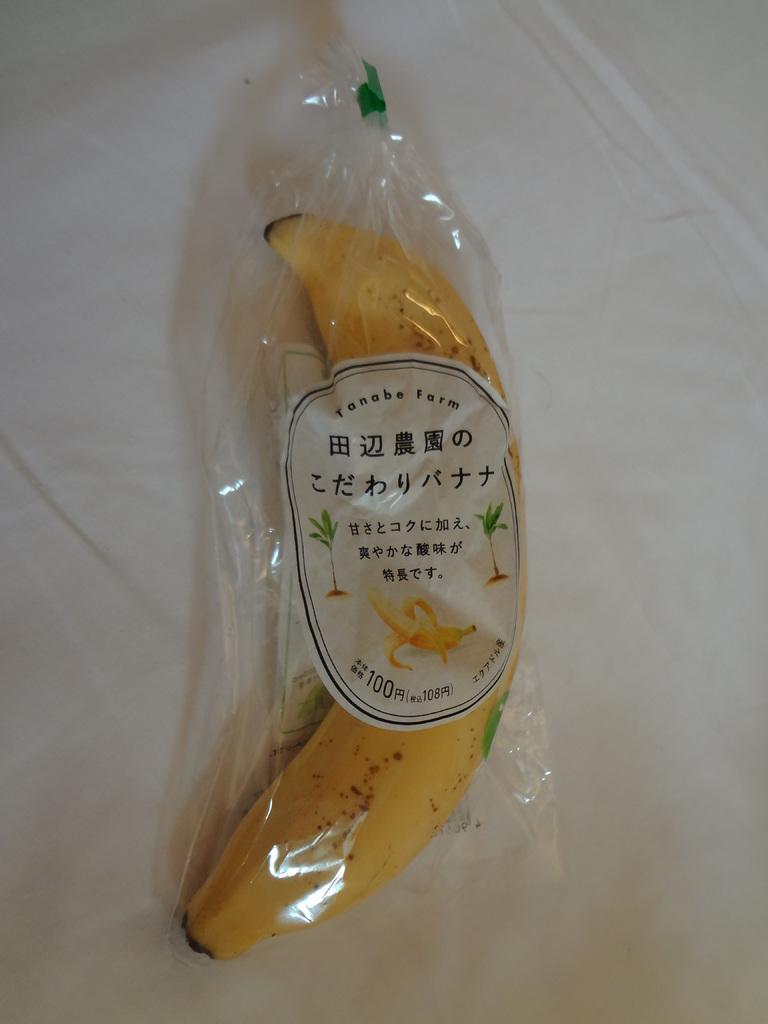What number is on the bottom of the label?
Your response must be concise. 100. 